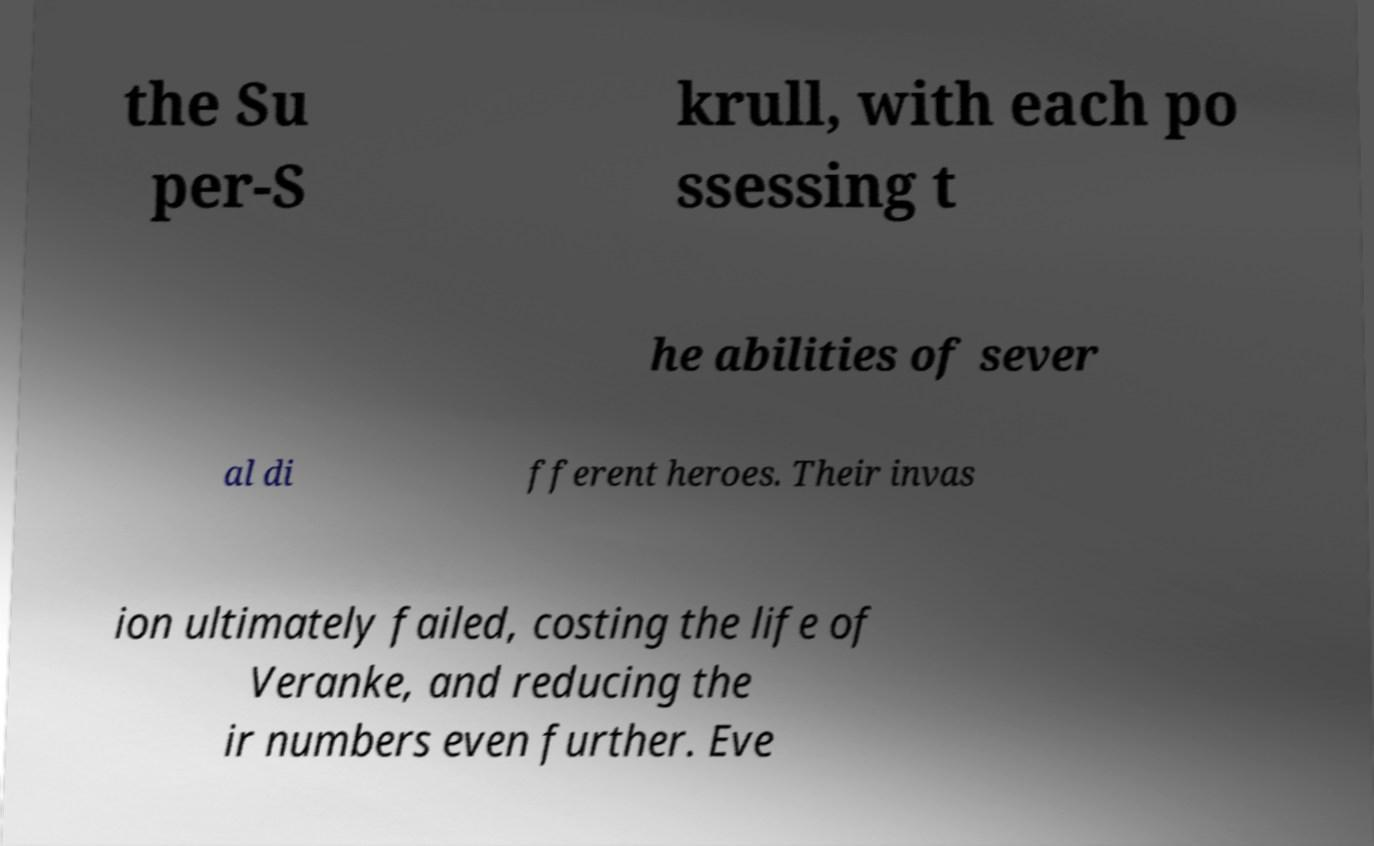There's text embedded in this image that I need extracted. Can you transcribe it verbatim? the Su per-S krull, with each po ssessing t he abilities of sever al di fferent heroes. Their invas ion ultimately failed, costing the life of Veranke, and reducing the ir numbers even further. Eve 